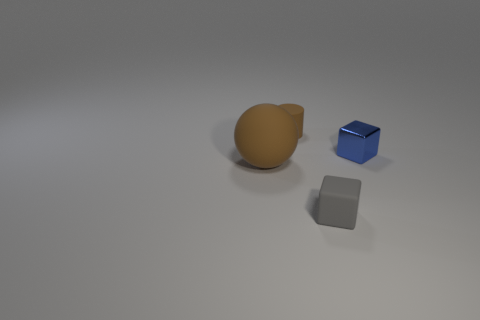Is there anything else of the same color as the tiny metal thing?
Keep it short and to the point. No. Is there a tiny matte cube behind the small object that is in front of the brown matte thing on the left side of the cylinder?
Ensure brevity in your answer.  No. Does the small thing that is behind the tiny blue shiny cube have the same color as the matte thing that is on the left side of the small brown matte cylinder?
Ensure brevity in your answer.  Yes. There is a gray object that is the same size as the brown matte cylinder; what is it made of?
Provide a short and direct response. Rubber. What is the size of the brown object in front of the tiny cube behind the brown thing that is in front of the tiny brown rubber cylinder?
Give a very brief answer. Large. How many other objects are the same material as the tiny brown cylinder?
Offer a terse response. 2. What size is the brown thing that is in front of the small blue block?
Keep it short and to the point. Large. What number of things are both right of the tiny brown thing and left of the tiny cylinder?
Give a very brief answer. 0. What is the object that is behind the thing that is on the right side of the tiny gray rubber thing made of?
Offer a terse response. Rubber. There is another object that is the same shape as the gray matte thing; what is it made of?
Provide a short and direct response. Metal. 